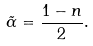Convert formula to latex. <formula><loc_0><loc_0><loc_500><loc_500>\tilde { \alpha } = \frac { 1 - n } { 2 } .</formula> 